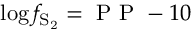<formula> <loc_0><loc_0><loc_500><loc_500>\log f _ { S _ { 2 } } = P P - 1 0</formula> 